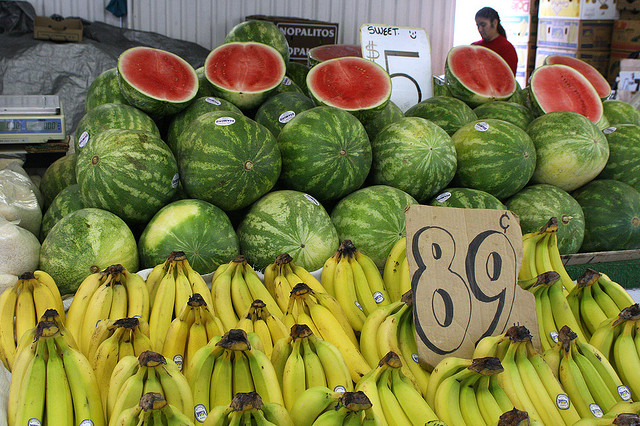Read and extract the text from this image. 89 C SWEET 5 NOPALITOS 